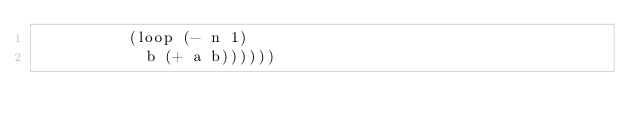Convert code to text. <code><loc_0><loc_0><loc_500><loc_500><_Scheme_>	      (loop (- n 1)
		    b (+ a b))))))
</code> 